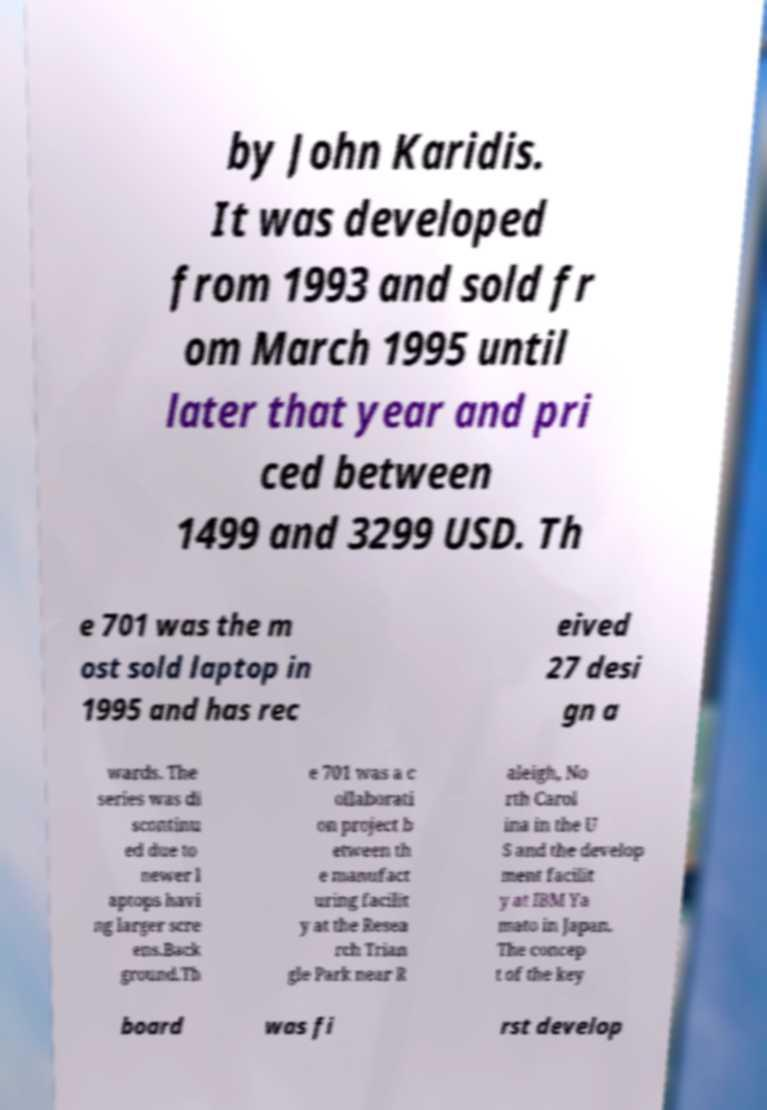Can you accurately transcribe the text from the provided image for me? by John Karidis. It was developed from 1993 and sold fr om March 1995 until later that year and pri ced between 1499 and 3299 USD. Th e 701 was the m ost sold laptop in 1995 and has rec eived 27 desi gn a wards. The series was di scontinu ed due to newer l aptops havi ng larger scre ens.Back ground.Th e 701 was a c ollaborati on project b etween th e manufact uring facilit y at the Resea rch Trian gle Park near R aleigh, No rth Carol ina in the U S and the develop ment facilit y at IBM Ya mato in Japan. The concep t of the key board was fi rst develop 